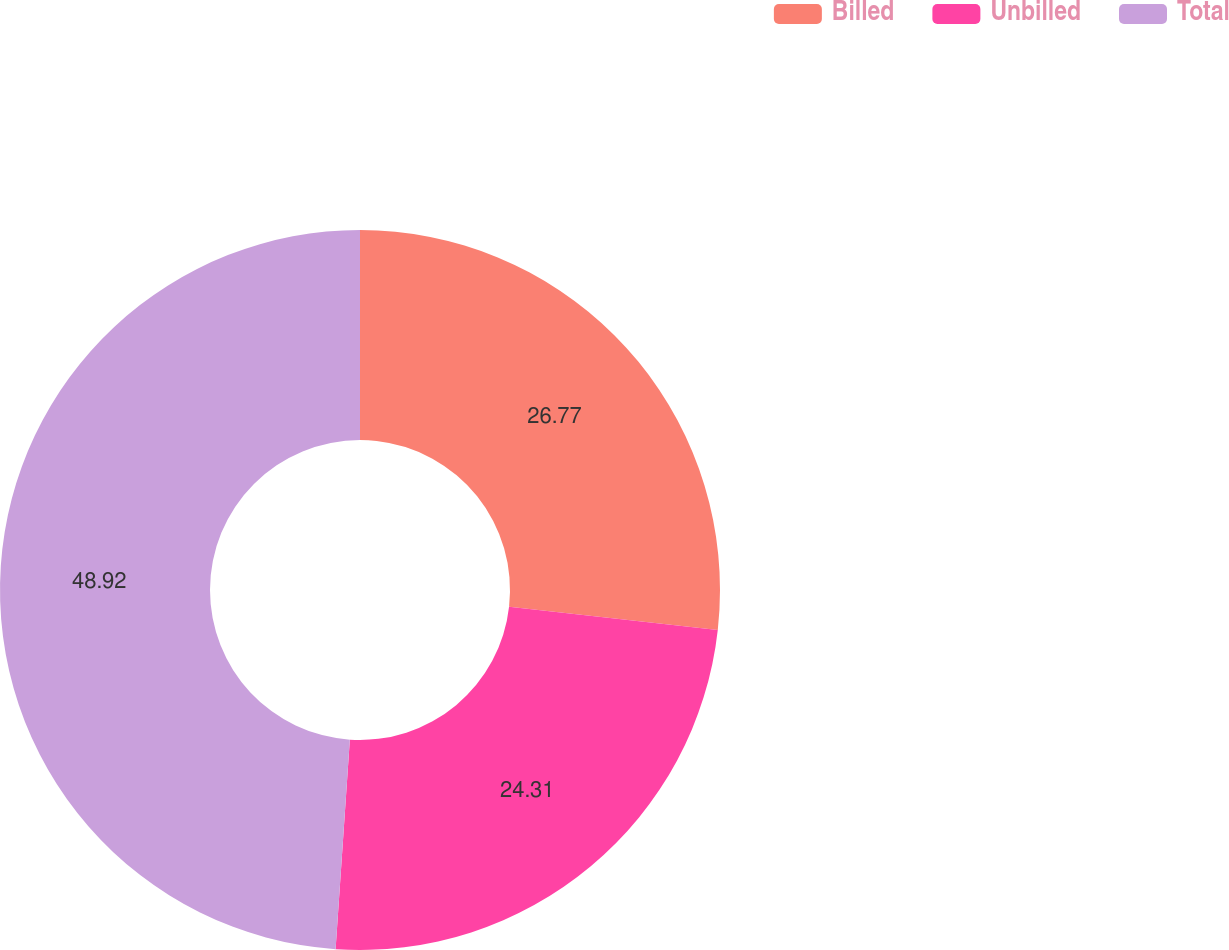Convert chart to OTSL. <chart><loc_0><loc_0><loc_500><loc_500><pie_chart><fcel>Billed<fcel>Unbilled<fcel>Total<nl><fcel>26.77%<fcel>24.31%<fcel>48.92%<nl></chart> 